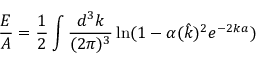Convert formula to latex. <formula><loc_0><loc_0><loc_500><loc_500>\frac { E } { A } = \frac { 1 } { 2 } \int \frac { d ^ { 3 } k } { ( 2 \pi ) ^ { 3 } } \ln ( 1 - \alpha ( \hat { k } ) ^ { 2 } e ^ { - 2 k a } )</formula> 